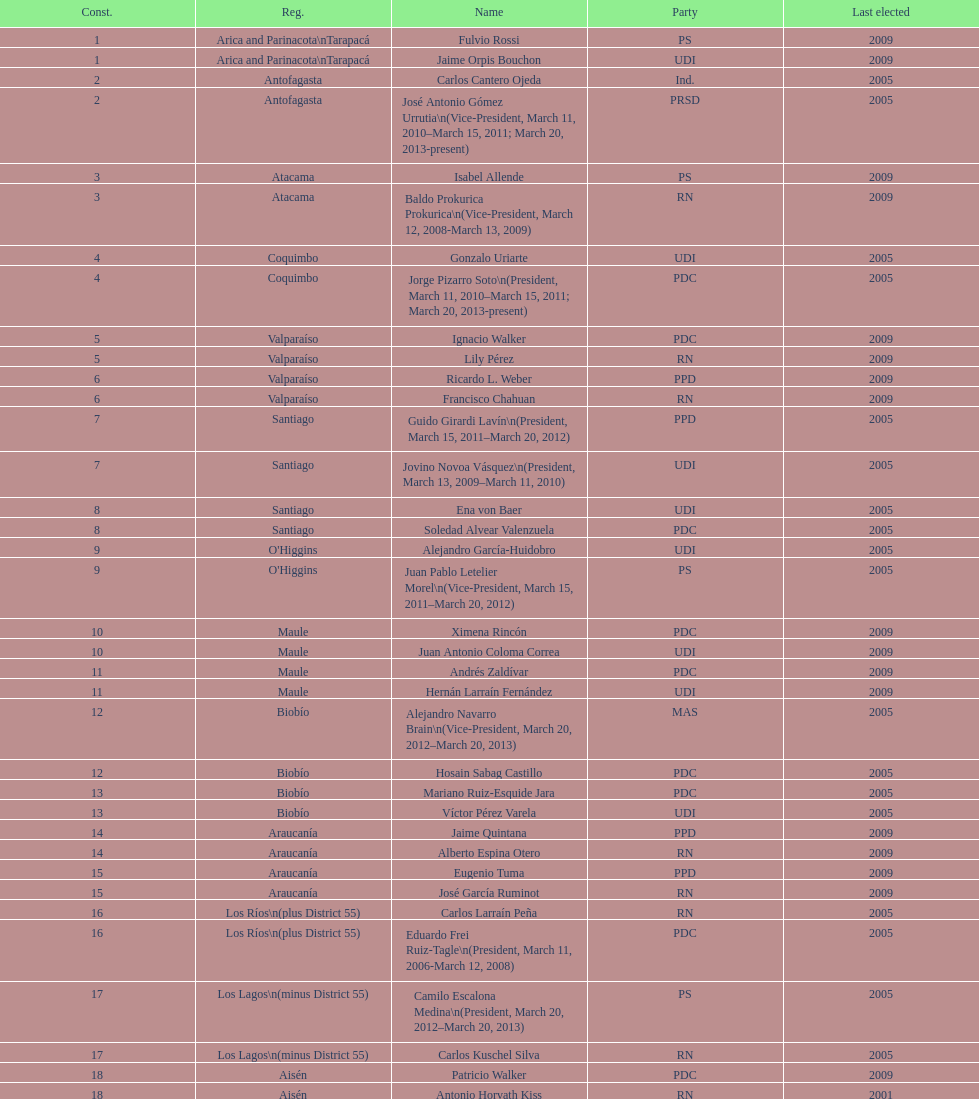Which party did jaime quintana belong to? PPD. 